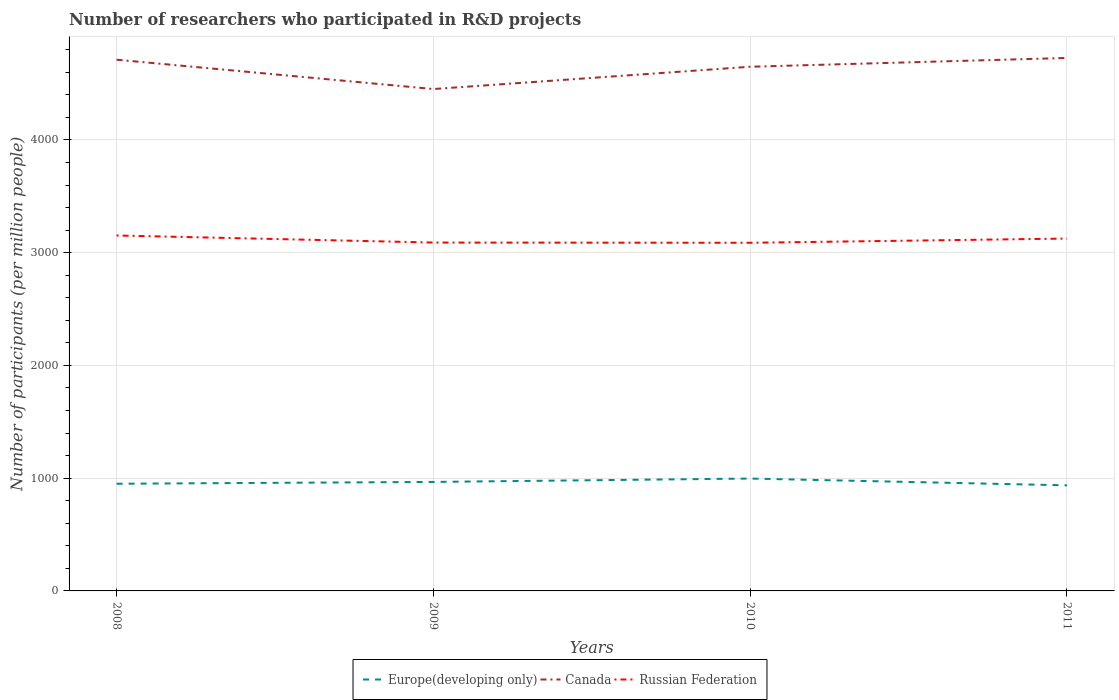Across all years, what is the maximum number of researchers who participated in R&D projects in Europe(developing only)?
Give a very brief answer. 936.45. In which year was the number of researchers who participated in R&D projects in Russian Federation maximum?
Your answer should be very brief. 2010. What is the total number of researchers who participated in R&D projects in Russian Federation in the graph?
Provide a short and direct response. 62.61. What is the difference between the highest and the second highest number of researchers who participated in R&D projects in Canada?
Your response must be concise. 275.84. Is the number of researchers who participated in R&D projects in Canada strictly greater than the number of researchers who participated in R&D projects in Russian Federation over the years?
Your response must be concise. No. How many years are there in the graph?
Your answer should be compact. 4. What is the title of the graph?
Make the answer very short. Number of researchers who participated in R&D projects. What is the label or title of the Y-axis?
Offer a very short reply. Number of participants (per million people). What is the Number of participants (per million people) in Europe(developing only) in 2008?
Your answer should be compact. 950.66. What is the Number of participants (per million people) of Canada in 2008?
Give a very brief answer. 4711.77. What is the Number of participants (per million people) of Russian Federation in 2008?
Provide a short and direct response. 3152.62. What is the Number of participants (per million people) of Europe(developing only) in 2009?
Offer a very short reply. 966.82. What is the Number of participants (per million people) in Canada in 2009?
Make the answer very short. 4451.42. What is the Number of participants (per million people) in Russian Federation in 2009?
Your response must be concise. 3090.01. What is the Number of participants (per million people) in Europe(developing only) in 2010?
Keep it short and to the point. 996.64. What is the Number of participants (per million people) in Canada in 2010?
Provide a short and direct response. 4649.22. What is the Number of participants (per million people) of Russian Federation in 2010?
Your response must be concise. 3087.99. What is the Number of participants (per million people) of Europe(developing only) in 2011?
Give a very brief answer. 936.45. What is the Number of participants (per million people) of Canada in 2011?
Make the answer very short. 4727.26. What is the Number of participants (per million people) in Russian Federation in 2011?
Your answer should be compact. 3125.3. Across all years, what is the maximum Number of participants (per million people) in Europe(developing only)?
Keep it short and to the point. 996.64. Across all years, what is the maximum Number of participants (per million people) in Canada?
Your response must be concise. 4727.26. Across all years, what is the maximum Number of participants (per million people) of Russian Federation?
Offer a terse response. 3152.62. Across all years, what is the minimum Number of participants (per million people) of Europe(developing only)?
Your answer should be compact. 936.45. Across all years, what is the minimum Number of participants (per million people) in Canada?
Your answer should be very brief. 4451.42. Across all years, what is the minimum Number of participants (per million people) of Russian Federation?
Offer a terse response. 3087.99. What is the total Number of participants (per million people) of Europe(developing only) in the graph?
Your answer should be compact. 3850.57. What is the total Number of participants (per million people) of Canada in the graph?
Your answer should be compact. 1.85e+04. What is the total Number of participants (per million people) of Russian Federation in the graph?
Your answer should be compact. 1.25e+04. What is the difference between the Number of participants (per million people) in Europe(developing only) in 2008 and that in 2009?
Ensure brevity in your answer.  -16.16. What is the difference between the Number of participants (per million people) of Canada in 2008 and that in 2009?
Make the answer very short. 260.35. What is the difference between the Number of participants (per million people) of Russian Federation in 2008 and that in 2009?
Offer a very short reply. 62.61. What is the difference between the Number of participants (per million people) in Europe(developing only) in 2008 and that in 2010?
Offer a terse response. -45.98. What is the difference between the Number of participants (per million people) of Canada in 2008 and that in 2010?
Offer a very short reply. 62.55. What is the difference between the Number of participants (per million people) in Russian Federation in 2008 and that in 2010?
Offer a terse response. 64.63. What is the difference between the Number of participants (per million people) in Europe(developing only) in 2008 and that in 2011?
Offer a very short reply. 14.21. What is the difference between the Number of participants (per million people) in Canada in 2008 and that in 2011?
Give a very brief answer. -15.49. What is the difference between the Number of participants (per million people) of Russian Federation in 2008 and that in 2011?
Your response must be concise. 27.32. What is the difference between the Number of participants (per million people) in Europe(developing only) in 2009 and that in 2010?
Ensure brevity in your answer.  -29.82. What is the difference between the Number of participants (per million people) of Canada in 2009 and that in 2010?
Give a very brief answer. -197.8. What is the difference between the Number of participants (per million people) in Russian Federation in 2009 and that in 2010?
Make the answer very short. 2.02. What is the difference between the Number of participants (per million people) of Europe(developing only) in 2009 and that in 2011?
Your answer should be compact. 30.37. What is the difference between the Number of participants (per million people) of Canada in 2009 and that in 2011?
Make the answer very short. -275.84. What is the difference between the Number of participants (per million people) in Russian Federation in 2009 and that in 2011?
Offer a terse response. -35.29. What is the difference between the Number of participants (per million people) in Europe(developing only) in 2010 and that in 2011?
Offer a very short reply. 60.19. What is the difference between the Number of participants (per million people) of Canada in 2010 and that in 2011?
Keep it short and to the point. -78.04. What is the difference between the Number of participants (per million people) in Russian Federation in 2010 and that in 2011?
Your answer should be very brief. -37.31. What is the difference between the Number of participants (per million people) of Europe(developing only) in 2008 and the Number of participants (per million people) of Canada in 2009?
Offer a very short reply. -3500.76. What is the difference between the Number of participants (per million people) of Europe(developing only) in 2008 and the Number of participants (per million people) of Russian Federation in 2009?
Keep it short and to the point. -2139.35. What is the difference between the Number of participants (per million people) of Canada in 2008 and the Number of participants (per million people) of Russian Federation in 2009?
Keep it short and to the point. 1621.76. What is the difference between the Number of participants (per million people) in Europe(developing only) in 2008 and the Number of participants (per million people) in Canada in 2010?
Provide a succinct answer. -3698.56. What is the difference between the Number of participants (per million people) of Europe(developing only) in 2008 and the Number of participants (per million people) of Russian Federation in 2010?
Your answer should be very brief. -2137.33. What is the difference between the Number of participants (per million people) of Canada in 2008 and the Number of participants (per million people) of Russian Federation in 2010?
Your answer should be very brief. 1623.78. What is the difference between the Number of participants (per million people) of Europe(developing only) in 2008 and the Number of participants (per million people) of Canada in 2011?
Provide a short and direct response. -3776.6. What is the difference between the Number of participants (per million people) in Europe(developing only) in 2008 and the Number of participants (per million people) in Russian Federation in 2011?
Ensure brevity in your answer.  -2174.64. What is the difference between the Number of participants (per million people) in Canada in 2008 and the Number of participants (per million people) in Russian Federation in 2011?
Your answer should be very brief. 1586.47. What is the difference between the Number of participants (per million people) in Europe(developing only) in 2009 and the Number of participants (per million people) in Canada in 2010?
Offer a terse response. -3682.4. What is the difference between the Number of participants (per million people) of Europe(developing only) in 2009 and the Number of participants (per million people) of Russian Federation in 2010?
Your answer should be very brief. -2121.17. What is the difference between the Number of participants (per million people) in Canada in 2009 and the Number of participants (per million people) in Russian Federation in 2010?
Give a very brief answer. 1363.43. What is the difference between the Number of participants (per million people) in Europe(developing only) in 2009 and the Number of participants (per million people) in Canada in 2011?
Provide a succinct answer. -3760.44. What is the difference between the Number of participants (per million people) of Europe(developing only) in 2009 and the Number of participants (per million people) of Russian Federation in 2011?
Make the answer very short. -2158.48. What is the difference between the Number of participants (per million people) in Canada in 2009 and the Number of participants (per million people) in Russian Federation in 2011?
Give a very brief answer. 1326.12. What is the difference between the Number of participants (per million people) in Europe(developing only) in 2010 and the Number of participants (per million people) in Canada in 2011?
Offer a very short reply. -3730.62. What is the difference between the Number of participants (per million people) in Europe(developing only) in 2010 and the Number of participants (per million people) in Russian Federation in 2011?
Give a very brief answer. -2128.66. What is the difference between the Number of participants (per million people) of Canada in 2010 and the Number of participants (per million people) of Russian Federation in 2011?
Offer a very short reply. 1523.92. What is the average Number of participants (per million people) of Europe(developing only) per year?
Your answer should be very brief. 962.64. What is the average Number of participants (per million people) in Canada per year?
Provide a succinct answer. 4634.92. What is the average Number of participants (per million people) in Russian Federation per year?
Offer a terse response. 3113.98. In the year 2008, what is the difference between the Number of participants (per million people) in Europe(developing only) and Number of participants (per million people) in Canada?
Offer a terse response. -3761.11. In the year 2008, what is the difference between the Number of participants (per million people) in Europe(developing only) and Number of participants (per million people) in Russian Federation?
Make the answer very short. -2201.96. In the year 2008, what is the difference between the Number of participants (per million people) in Canada and Number of participants (per million people) in Russian Federation?
Provide a short and direct response. 1559.15. In the year 2009, what is the difference between the Number of participants (per million people) of Europe(developing only) and Number of participants (per million people) of Canada?
Keep it short and to the point. -3484.6. In the year 2009, what is the difference between the Number of participants (per million people) of Europe(developing only) and Number of participants (per million people) of Russian Federation?
Give a very brief answer. -2123.19. In the year 2009, what is the difference between the Number of participants (per million people) in Canada and Number of participants (per million people) in Russian Federation?
Your response must be concise. 1361.41. In the year 2010, what is the difference between the Number of participants (per million people) in Europe(developing only) and Number of participants (per million people) in Canada?
Give a very brief answer. -3652.58. In the year 2010, what is the difference between the Number of participants (per million people) of Europe(developing only) and Number of participants (per million people) of Russian Federation?
Make the answer very short. -2091.35. In the year 2010, what is the difference between the Number of participants (per million people) in Canada and Number of participants (per million people) in Russian Federation?
Your answer should be compact. 1561.23. In the year 2011, what is the difference between the Number of participants (per million people) in Europe(developing only) and Number of participants (per million people) in Canada?
Make the answer very short. -3790.81. In the year 2011, what is the difference between the Number of participants (per million people) of Europe(developing only) and Number of participants (per million people) of Russian Federation?
Provide a short and direct response. -2188.85. In the year 2011, what is the difference between the Number of participants (per million people) of Canada and Number of participants (per million people) of Russian Federation?
Provide a short and direct response. 1601.96. What is the ratio of the Number of participants (per million people) in Europe(developing only) in 2008 to that in 2009?
Your answer should be compact. 0.98. What is the ratio of the Number of participants (per million people) in Canada in 2008 to that in 2009?
Provide a succinct answer. 1.06. What is the ratio of the Number of participants (per million people) in Russian Federation in 2008 to that in 2009?
Give a very brief answer. 1.02. What is the ratio of the Number of participants (per million people) of Europe(developing only) in 2008 to that in 2010?
Offer a terse response. 0.95. What is the ratio of the Number of participants (per million people) of Canada in 2008 to that in 2010?
Make the answer very short. 1.01. What is the ratio of the Number of participants (per million people) in Russian Federation in 2008 to that in 2010?
Offer a terse response. 1.02. What is the ratio of the Number of participants (per million people) of Europe(developing only) in 2008 to that in 2011?
Ensure brevity in your answer.  1.02. What is the ratio of the Number of participants (per million people) of Russian Federation in 2008 to that in 2011?
Keep it short and to the point. 1.01. What is the ratio of the Number of participants (per million people) of Europe(developing only) in 2009 to that in 2010?
Ensure brevity in your answer.  0.97. What is the ratio of the Number of participants (per million people) in Canada in 2009 to that in 2010?
Ensure brevity in your answer.  0.96. What is the ratio of the Number of participants (per million people) in Russian Federation in 2009 to that in 2010?
Ensure brevity in your answer.  1. What is the ratio of the Number of participants (per million people) in Europe(developing only) in 2009 to that in 2011?
Provide a short and direct response. 1.03. What is the ratio of the Number of participants (per million people) in Canada in 2009 to that in 2011?
Your answer should be very brief. 0.94. What is the ratio of the Number of participants (per million people) of Russian Federation in 2009 to that in 2011?
Make the answer very short. 0.99. What is the ratio of the Number of participants (per million people) in Europe(developing only) in 2010 to that in 2011?
Your response must be concise. 1.06. What is the ratio of the Number of participants (per million people) of Canada in 2010 to that in 2011?
Your answer should be very brief. 0.98. What is the difference between the highest and the second highest Number of participants (per million people) of Europe(developing only)?
Offer a terse response. 29.82. What is the difference between the highest and the second highest Number of participants (per million people) in Canada?
Offer a very short reply. 15.49. What is the difference between the highest and the second highest Number of participants (per million people) of Russian Federation?
Offer a terse response. 27.32. What is the difference between the highest and the lowest Number of participants (per million people) in Europe(developing only)?
Give a very brief answer. 60.19. What is the difference between the highest and the lowest Number of participants (per million people) of Canada?
Provide a short and direct response. 275.84. What is the difference between the highest and the lowest Number of participants (per million people) of Russian Federation?
Give a very brief answer. 64.63. 